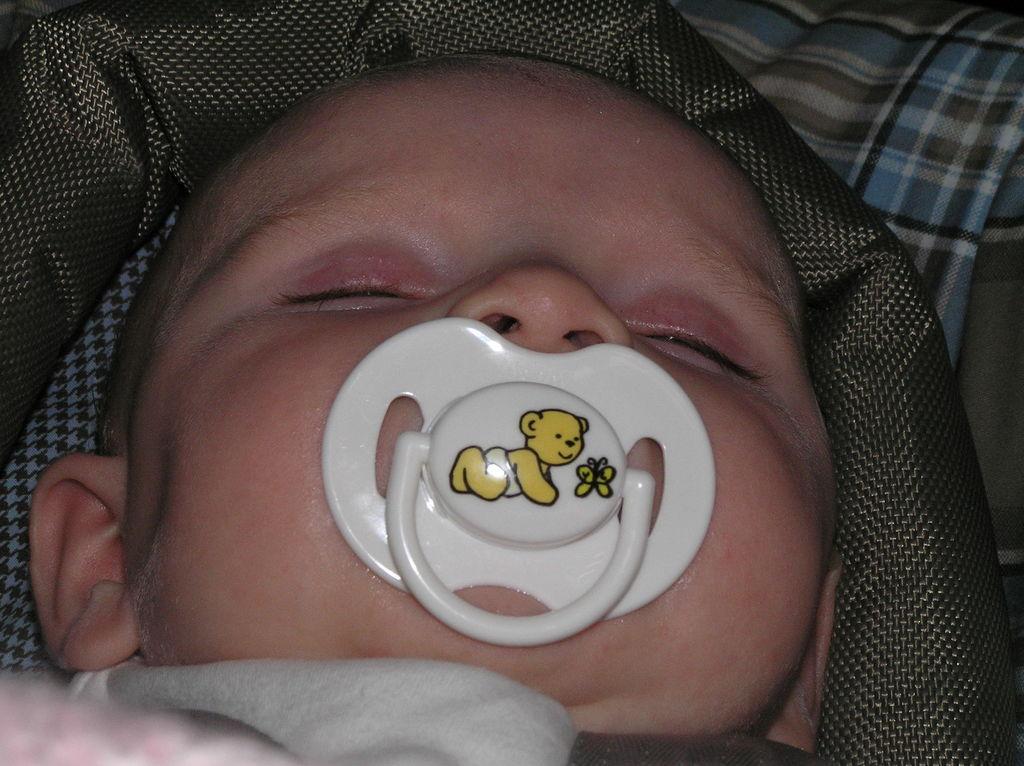Can you describe this image briefly? In this image we can see a baby with a pacifier. In the background of the image there are clothes. 